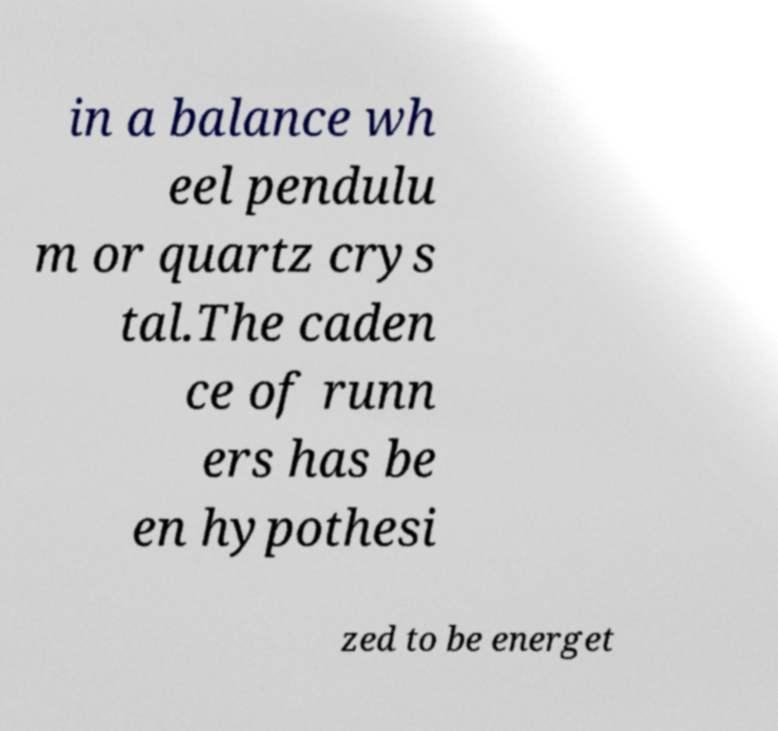Can you accurately transcribe the text from the provided image for me? in a balance wh eel pendulu m or quartz crys tal.The caden ce of runn ers has be en hypothesi zed to be energet 